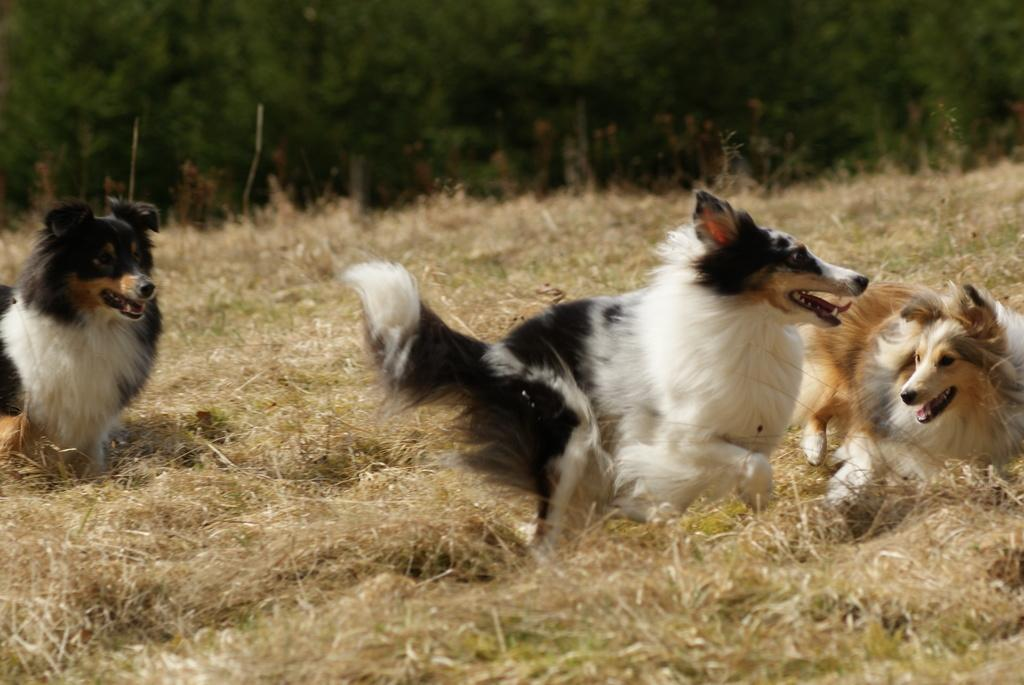How many dogs are present in the image? There are three dogs in the image. Where are the dogs located? The dogs are on a grassland. What can be seen in the background of the image? There are trees in the background of the image. How is the background of the image depicted? The background is blurred. What type of organization is responsible for the dogs' health in the image? There is no information about the dogs' health or any organization in the image. 